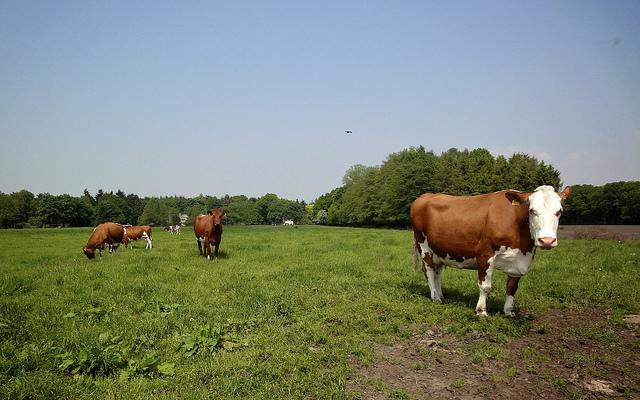How many cows are looking at the camera? two 